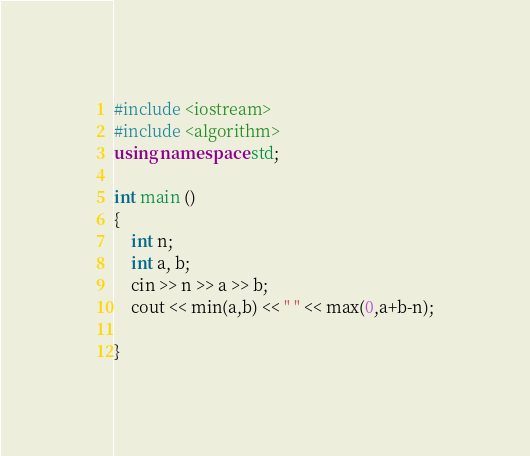<code> <loc_0><loc_0><loc_500><loc_500><_C++_>#include <iostream>
#include <algorithm>
using namespace std;

int main ()
{
    int n;
    int a, b;
    cin >> n >> a >> b;
    cout << min(a,b) << " " << max(0,a+b-n);

}</code> 